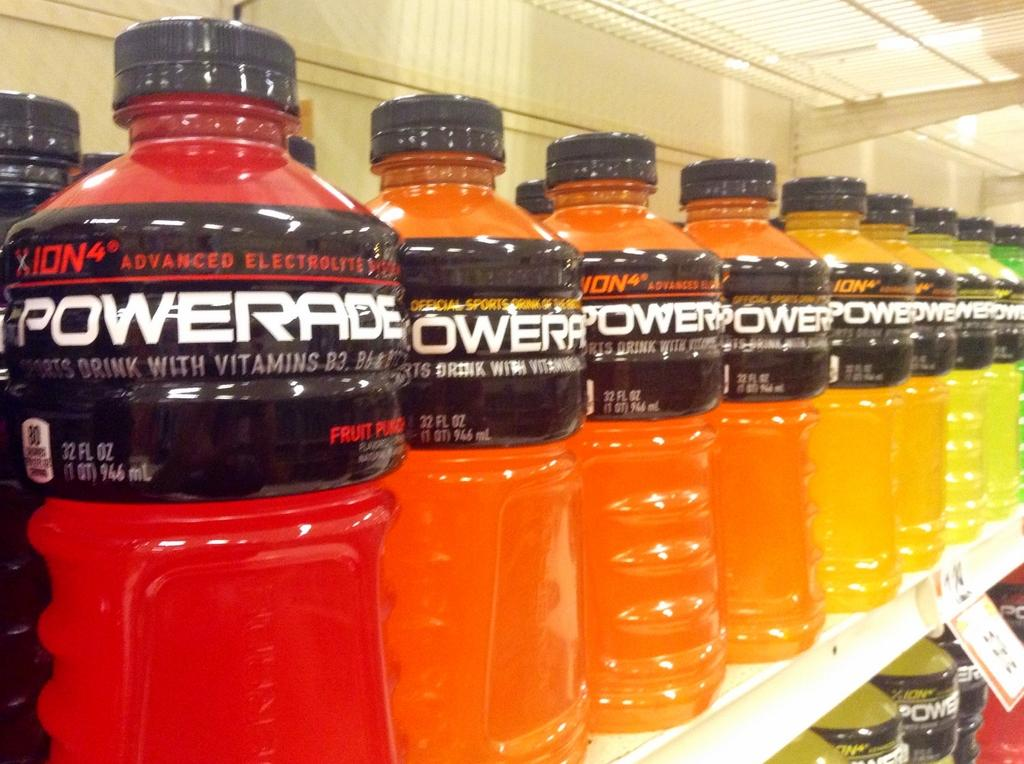<image>
Provide a brief description of the given image. lots of flavor of powerrade at the grocery store 